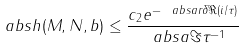Convert formula to latex. <formula><loc_0><loc_0><loc_500><loc_500>\ a b s { h ( M , N , b ) } \leq \frac { c _ { 2 } e ^ { - \ a b s { a } r \delta \Re ( i / \tau ) } } { \ a b s { a \Im \tau ^ { - 1 } } }</formula> 